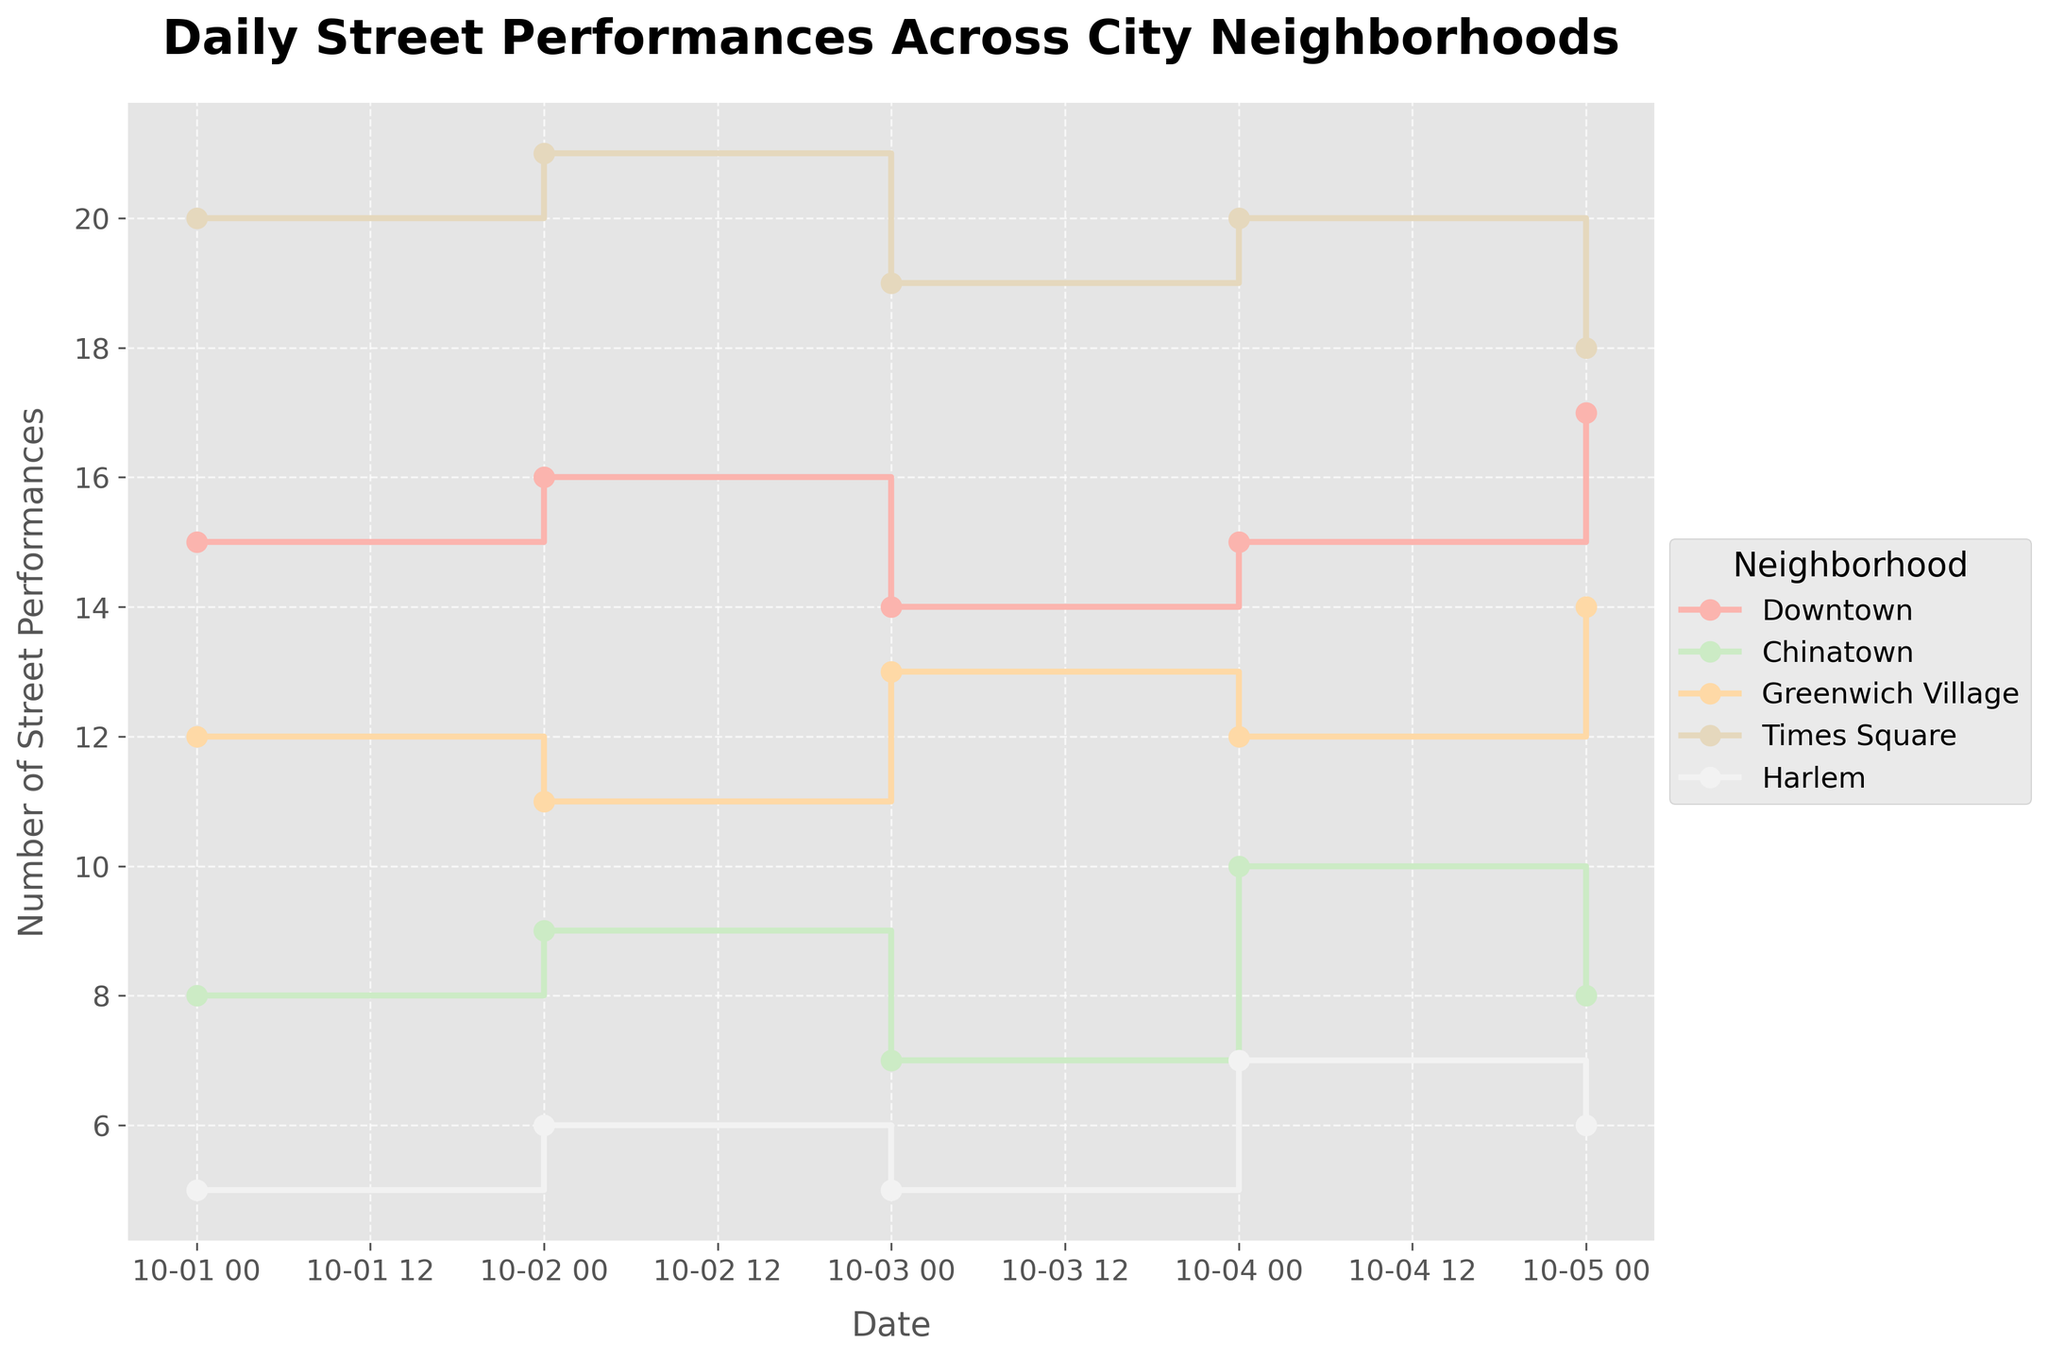How many neighborhood lines are plotted in the figure? The number of neighborhood lines is shown by the number of unique labels in the legend. Each neighborhood is represented by a unique color and name.
Answer: 5 Which neighborhood had the highest number of street performances on October 1st? The figure shows the number of street performances for each neighborhood on October 1st. By checking the y-axis value for each neighborhood on this date, the highest value is for Times Square.
Answer: Times Square Which neighborhood had the least number of street performances consistently throughout the days? By comparing the lines, the neighborhood with the lowest y-axis values across multiple dates is Harlem.
Answer: Harlem What is the average number of performances in Downtown across the given dates? Add the number of daily performances in Downtown (15, 16, 14, 15, 17) and divide by the number of days (5). The sum is 77, and the average is 77/5 = 15.4.
Answer: 15.4 How does the number of performances in Chinatown on October 4th compare to October 5th? Check the y-values for Chinatown on both dates. On October 4th, it's at 10, and on October 5th, it's at 8.
Answer: It decreased Which two neighborhoods had the same number of street performances on October 4th? Look at the y-axis values for performances on October 4th. Both Downtown and Times Square show a value of 20.
Answer: Downtown and Times Square Calculate the difference in street performances between Greenwich Village and Harlem on October 2nd. For October 2nd, Greenwich Village has 11 performances and Harlem has 6. Subtract 6 from 11 to get the difference.
Answer: 5 Which neighborhood shows the most variability (fluctuation) in the number of daily performances? Compare the step heights (differences in y-axis values between consecutive dates) for each neighborhood. Times Square shows significant changes between days like 20 to 21 and back to 19.
Answer: Times Square On which date did Times Square have its lowest number of street performances in this dataset? Identify the y-axis values for Times Square across all dates. The lowest value is 18 on October 5th.
Answer: October 5th 